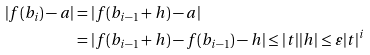Convert formula to latex. <formula><loc_0><loc_0><loc_500><loc_500>| f ( b _ { i } ) - a | & = | f ( b _ { i - 1 } + h ) - a | \\ & = | f ( b _ { i - 1 } + h ) - f ( b _ { i - 1 } ) - h | \leq | t | | h | \leq \varepsilon | t | ^ { i }</formula> 